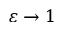<formula> <loc_0><loc_0><loc_500><loc_500>\varepsilon \to 1</formula> 